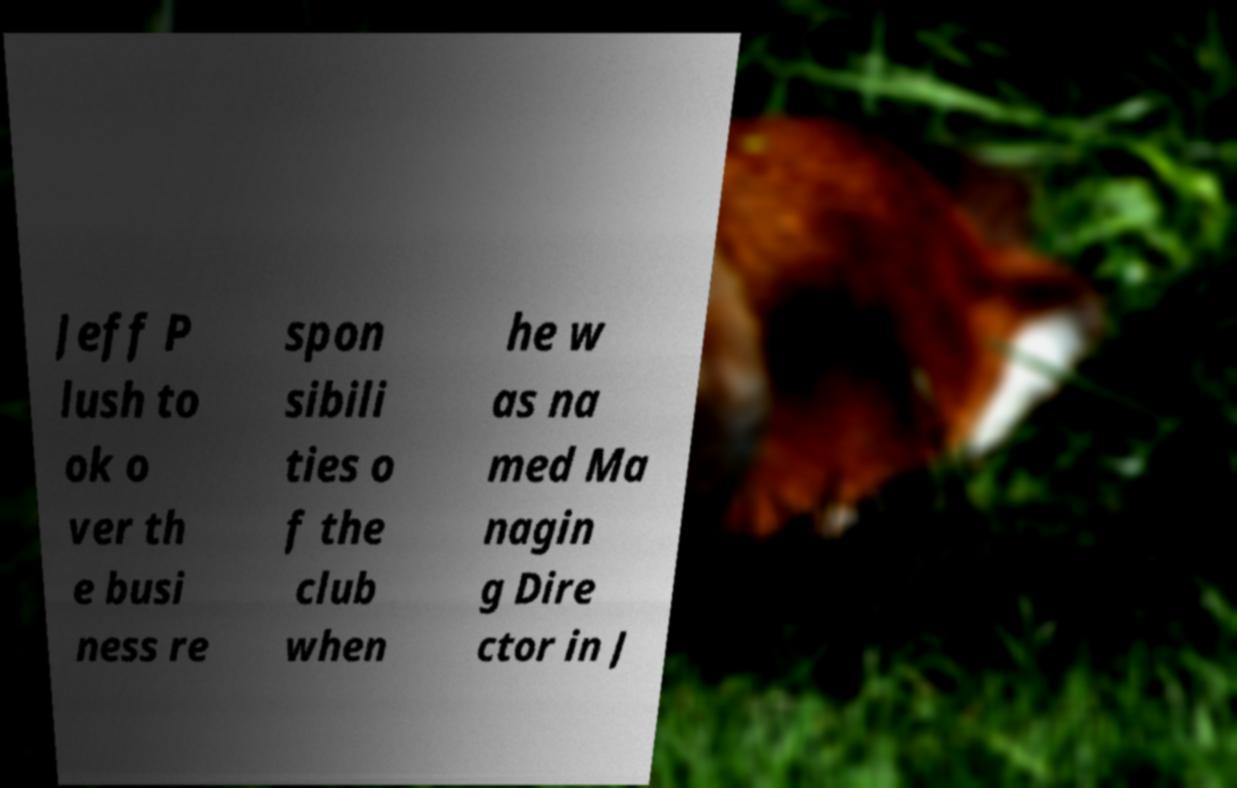Could you extract and type out the text from this image? Jeff P lush to ok o ver th e busi ness re spon sibili ties o f the club when he w as na med Ma nagin g Dire ctor in J 